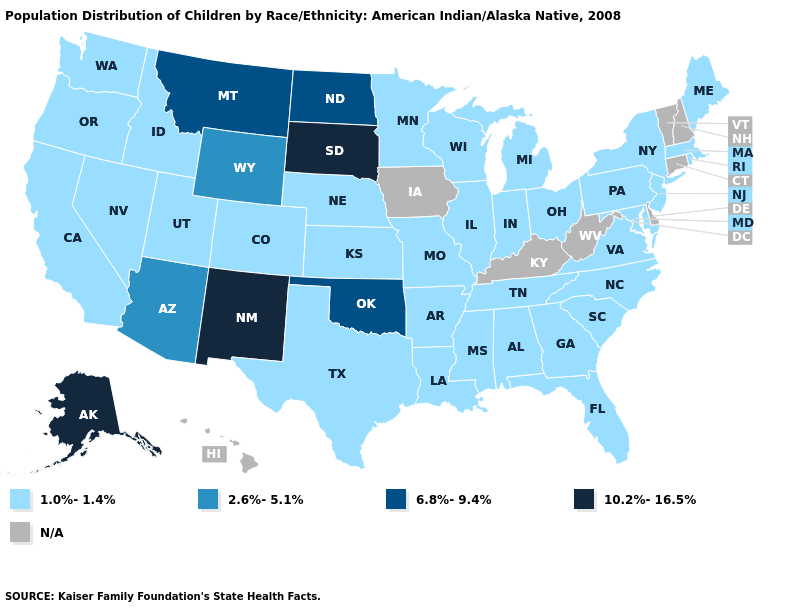What is the value of Pennsylvania?
Write a very short answer. 1.0%-1.4%. What is the value of Minnesota?
Give a very brief answer. 1.0%-1.4%. What is the highest value in states that border Georgia?
Be succinct. 1.0%-1.4%. Which states have the lowest value in the USA?
Answer briefly. Alabama, Arkansas, California, Colorado, Florida, Georgia, Idaho, Illinois, Indiana, Kansas, Louisiana, Maine, Maryland, Massachusetts, Michigan, Minnesota, Mississippi, Missouri, Nebraska, Nevada, New Jersey, New York, North Carolina, Ohio, Oregon, Pennsylvania, Rhode Island, South Carolina, Tennessee, Texas, Utah, Virginia, Washington, Wisconsin. Name the states that have a value in the range 1.0%-1.4%?
Keep it brief. Alabama, Arkansas, California, Colorado, Florida, Georgia, Idaho, Illinois, Indiana, Kansas, Louisiana, Maine, Maryland, Massachusetts, Michigan, Minnesota, Mississippi, Missouri, Nebraska, Nevada, New Jersey, New York, North Carolina, Ohio, Oregon, Pennsylvania, Rhode Island, South Carolina, Tennessee, Texas, Utah, Virginia, Washington, Wisconsin. What is the value of Washington?
Short answer required. 1.0%-1.4%. How many symbols are there in the legend?
Answer briefly. 5. Does the first symbol in the legend represent the smallest category?
Be succinct. Yes. Which states have the lowest value in the Northeast?
Concise answer only. Maine, Massachusetts, New Jersey, New York, Pennsylvania, Rhode Island. Among the states that border Rhode Island , which have the highest value?
Keep it brief. Massachusetts. What is the value of Wyoming?
Keep it brief. 2.6%-5.1%. Name the states that have a value in the range 1.0%-1.4%?
Short answer required. Alabama, Arkansas, California, Colorado, Florida, Georgia, Idaho, Illinois, Indiana, Kansas, Louisiana, Maine, Maryland, Massachusetts, Michigan, Minnesota, Mississippi, Missouri, Nebraska, Nevada, New Jersey, New York, North Carolina, Ohio, Oregon, Pennsylvania, Rhode Island, South Carolina, Tennessee, Texas, Utah, Virginia, Washington, Wisconsin. Does Colorado have the lowest value in the USA?
Concise answer only. Yes. 